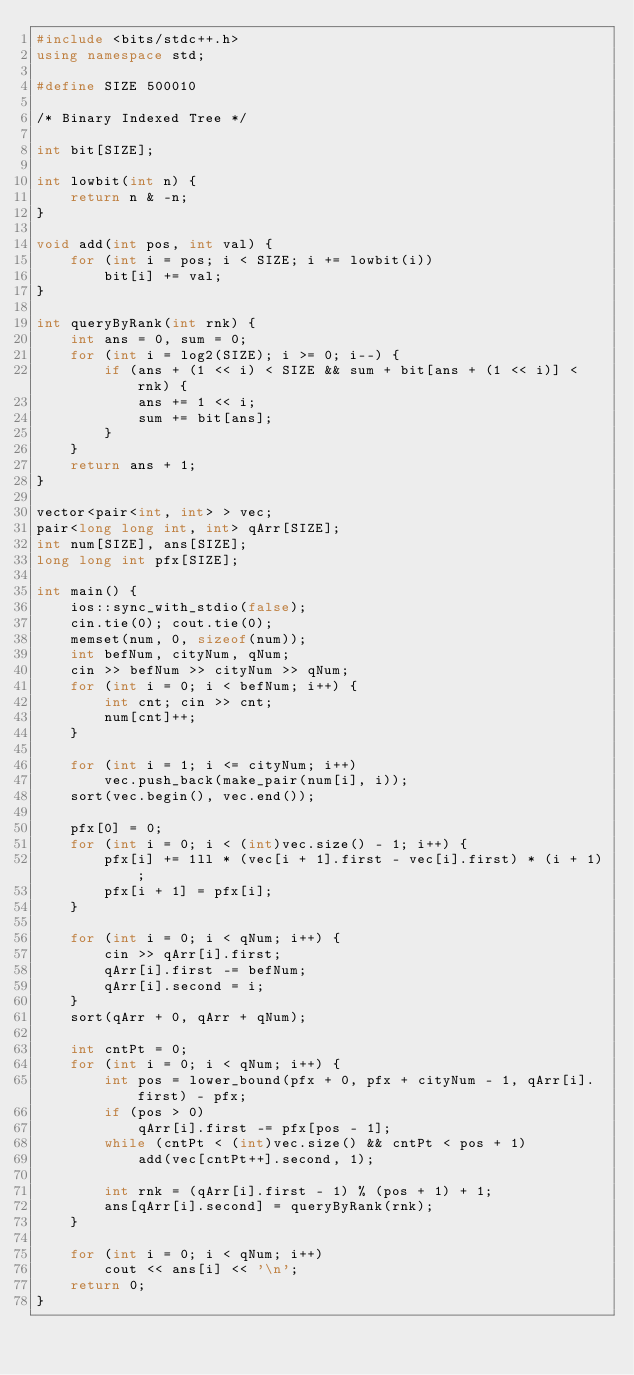<code> <loc_0><loc_0><loc_500><loc_500><_C++_>#include <bits/stdc++.h>
using namespace std;

#define SIZE 500010

/* Binary Indexed Tree */

int bit[SIZE];

int lowbit(int n) {
    return n & -n;
}

void add(int pos, int val) {
    for (int i = pos; i < SIZE; i += lowbit(i))
        bit[i] += val;
}

int queryByRank(int rnk) {
    int ans = 0, sum = 0;
    for (int i = log2(SIZE); i >= 0; i--) {
        if (ans + (1 << i) < SIZE && sum + bit[ans + (1 << i)] < rnk) {
            ans += 1 << i;
            sum += bit[ans];
        }
    }
    return ans + 1;
}

vector<pair<int, int> > vec;
pair<long long int, int> qArr[SIZE];
int num[SIZE], ans[SIZE];
long long int pfx[SIZE];

int main() {
    ios::sync_with_stdio(false);
    cin.tie(0); cout.tie(0);
    memset(num, 0, sizeof(num));
    int befNum, cityNum, qNum;
    cin >> befNum >> cityNum >> qNum;
    for (int i = 0; i < befNum; i++) {
        int cnt; cin >> cnt;
        num[cnt]++;
    }

    for (int i = 1; i <= cityNum; i++)
        vec.push_back(make_pair(num[i], i));
    sort(vec.begin(), vec.end());

    pfx[0] = 0;
    for (int i = 0; i < (int)vec.size() - 1; i++) {
        pfx[i] += 1ll * (vec[i + 1].first - vec[i].first) * (i + 1);
        pfx[i + 1] = pfx[i];
    }

    for (int i = 0; i < qNum; i++) {
        cin >> qArr[i].first;
        qArr[i].first -= befNum;
        qArr[i].second = i;
    }
    sort(qArr + 0, qArr + qNum);

    int cntPt = 0;
    for (int i = 0; i < qNum; i++) {
        int pos = lower_bound(pfx + 0, pfx + cityNum - 1, qArr[i].first) - pfx;
        if (pos > 0)
            qArr[i].first -= pfx[pos - 1];
        while (cntPt < (int)vec.size() && cntPt < pos + 1)
            add(vec[cntPt++].second, 1);
        
        int rnk = (qArr[i].first - 1) % (pos + 1) + 1;
        ans[qArr[i].second] = queryByRank(rnk);
    }

    for (int i = 0; i < qNum; i++)
        cout << ans[i] << '\n';
    return 0;
}</code> 